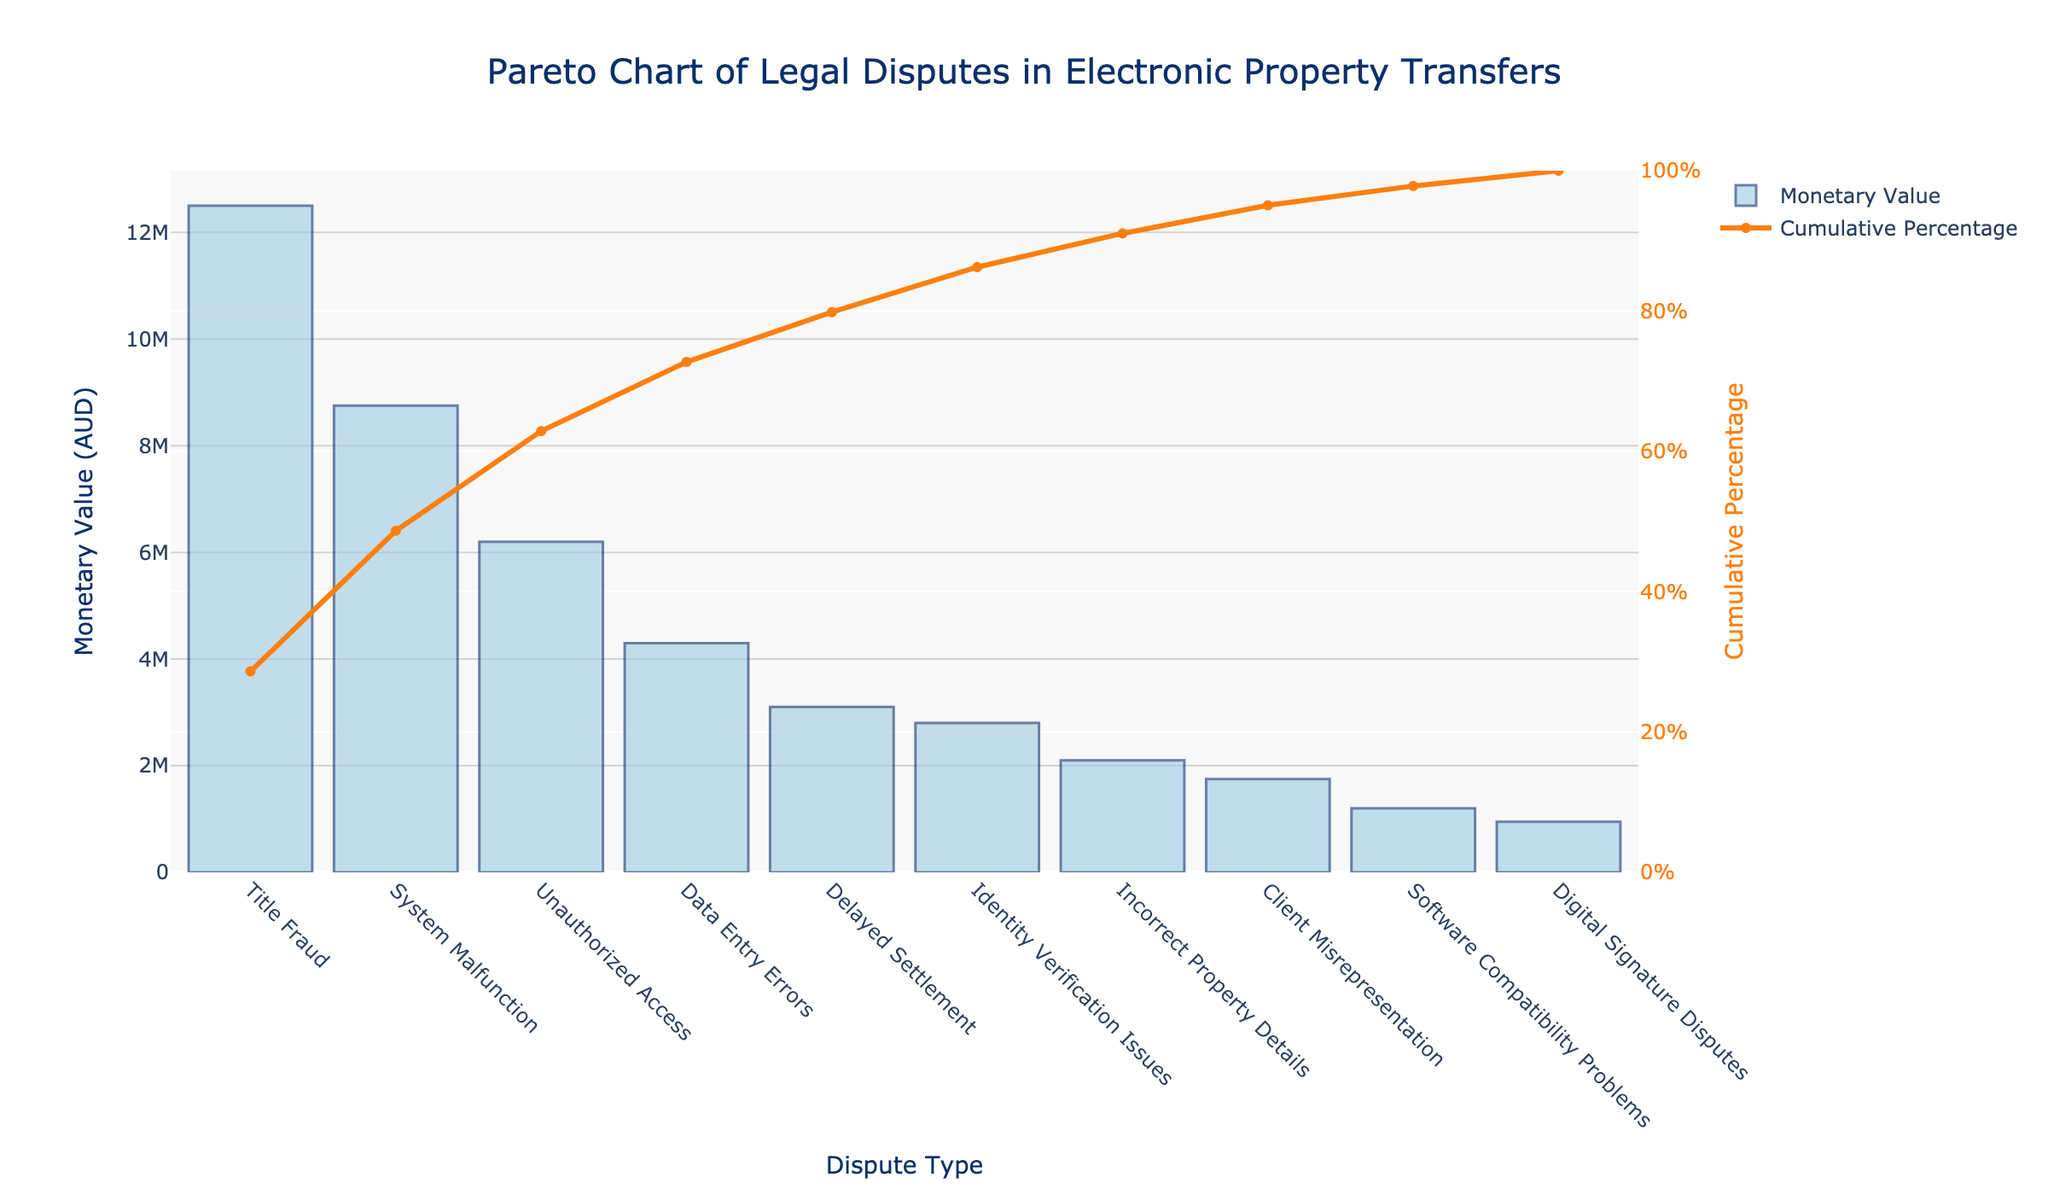What's the title of the figure? The title of the figure is displayed at the top of the chart in a larger font size. It describes the content of the figure.
Answer: Pareto Chart of Legal Disputes in Electronic Property Transfers How many dispute types are listed in the chart? By counting the distinct bars in the bar chart or by counting the x-axis labels, we can determine the total number of dispute types.
Answer: 10 Which dispute type has the highest monetary value? The dispute type with the tallest bar in the bar chart, located at the leftmost position, represents the one with the highest monetary value.
Answer: Title Fraud What's the cumulative percentage for 'System Malfunction'? The cumulative percentage for 'System Malfunction' is found on the secondary y-axis, corresponding to the position of the bar labeled 'System Malfunction.'
Answer: 54.1% What's the combined monetary value of 'Data Entry Errors' and 'Delayed Settlement'? Add the monetary values of 'Data Entry Errors' and 'Delayed Settlement', which are 4,300,000 AUD and 3,100,000 AUD respectively.
Answer: 7,400,000 AUD Which dispute type contributes the least to the overall monetary value? The dispute type with the smallest bar in the bar chart, located at the rightmost position, represents the one with the least monetary value.
Answer: Digital Signature Disputes What is the difference in monetary value between 'Unauthorized Access' and 'Identity Verification Issues'? Subtract the monetary value of 'Identity Verification Issues' from 'Unauthorized Access'. This difference is 6,200,000 AUD - 2,800,000 AUD.
Answer: 3,400,000 AUD Between 'Incorrect Property Details' and 'Client Misrepresentation', which dispute type has a higher monetary value? By comparing the heights of the bars for 'Incorrect Property Details' and 'Client Misrepresentation', we can see which has a higher value.
Answer: Incorrect Property Details How much monetary value do the top three dispute types represent together? Sum the monetary values of the top three dispute types: 'Title Fraud', 'System Malfunction', and 'Unauthorized Access'. These are 12,500,000 AUD, 8,750,000 AUD, and 6,200,000 AUD respectively.
Answer: 27,450,000 AUD What is the cumulative percentage for the top five dispute types? Find the cumulative percentage at the fifth position on the Pareto line, which includes 'Title Fraud', 'System Malfunction', 'Unauthorized Access', 'Data Entry Errors', 'Delayed Settlement'.
Answer: 86.8% 